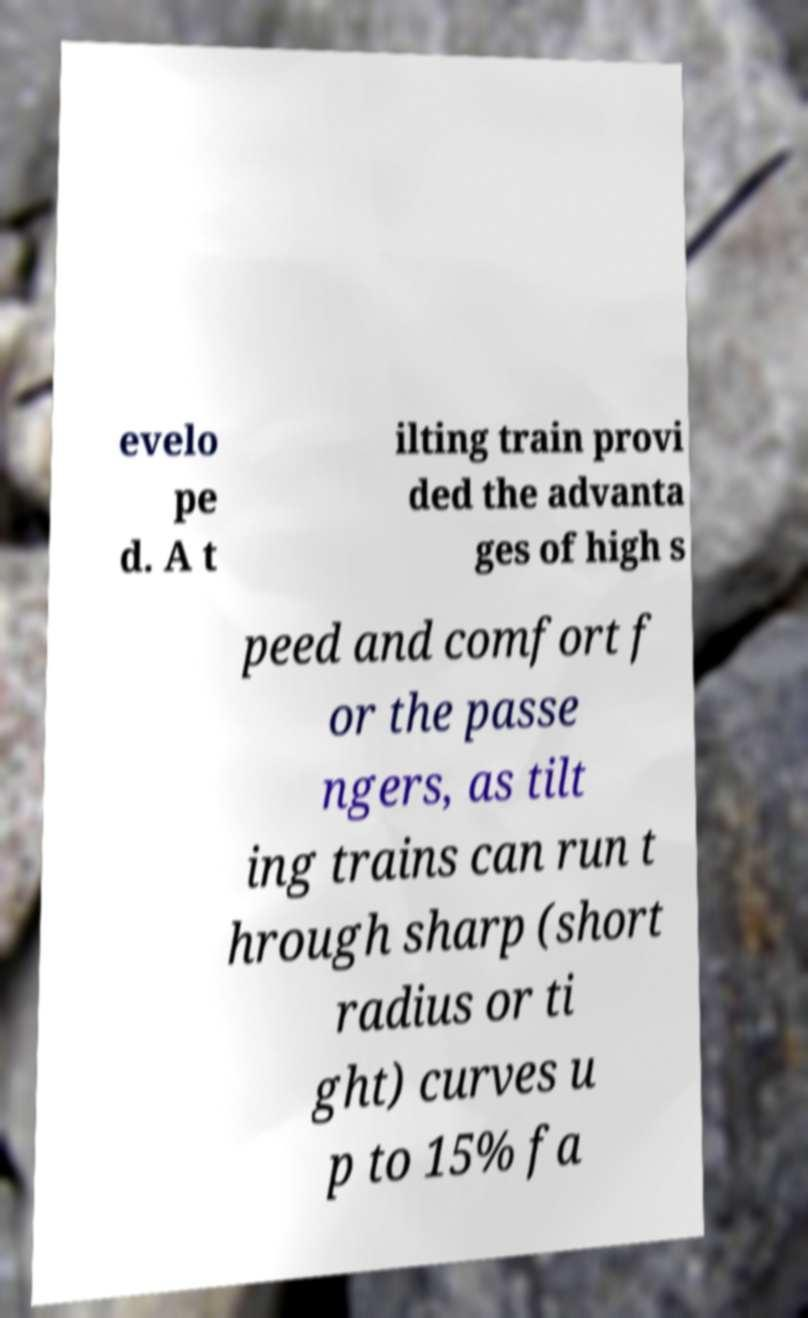For documentation purposes, I need the text within this image transcribed. Could you provide that? evelo pe d. A t ilting train provi ded the advanta ges of high s peed and comfort f or the passe ngers, as tilt ing trains can run t hrough sharp (short radius or ti ght) curves u p to 15% fa 